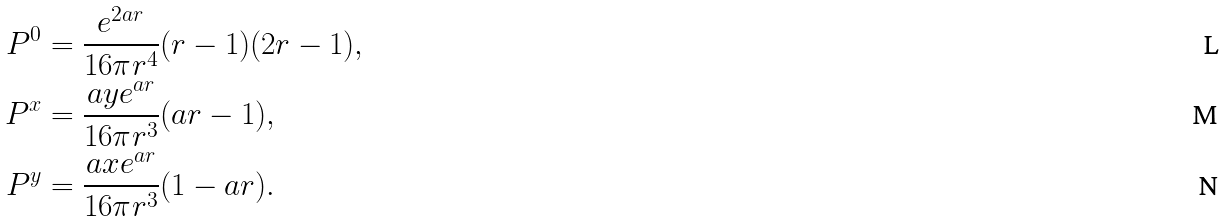<formula> <loc_0><loc_0><loc_500><loc_500>P ^ { 0 } & = \frac { e ^ { 2 a r } } { 1 6 \pi r ^ { 4 } } ( r - 1 ) ( 2 r - 1 ) , \\ P ^ { x } & = \frac { a y e ^ { a r } } { 1 6 \pi r ^ { 3 } } ( a r - 1 ) , \\ P ^ { y } & = \frac { a x e ^ { a r } } { 1 6 \pi r ^ { 3 } } ( 1 - a r ) .</formula> 